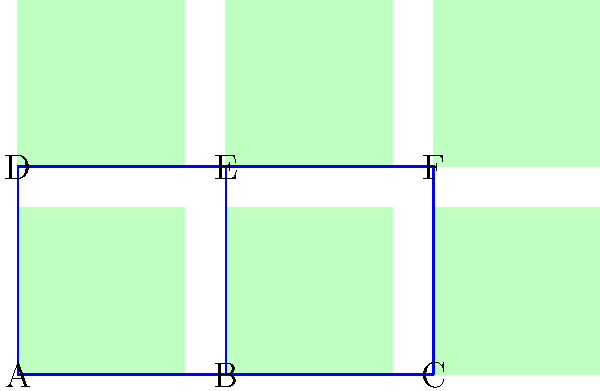As a curator optimizing gallery space, you need to partition the given layout into two equal sections for different exhibitions. The graph represents six rooms (A-F) in the gallery, with edges indicating adjacent rooms. What is the minimum number of connections between rooms that need to be removed to create two separate sections of equal size? To solve this problem, we'll use the concept of graph partitioning:

1. The gallery has 6 rooms in total, so we need to create two sections with 3 rooms each.

2. We need to find a cut that separates the graph into two equal parts while minimizing the number of edges cut.

3. Examining the layout, we can see that there are several ways to partition the rooms:
   a) (A, B, D) and (C, E, F)
   b) (A, D, E) and (B, C, F)
   c) (B, D, E) and (A, C, F)

4. Let's count the number of edges that need to be cut for each partition:
   a) (A, B, D) and (C, E, F): 2 edges (B-C and D-E)
   b) (A, D, E) and (B, C, F): 3 edges (A-B, D-B, and E-F)
   c) (B, D, E) and (A, C, F): 3 edges (A-B, A-D, and E-F)

5. The minimum number of connections that need to be removed is 2, achieved by partitioning the rooms into (A, B, D) and (C, E, F).

This partition allows for two equal sections while minimizing the number of connections between them, optimizing the gallery space for two separate exhibitions.
Answer: 2 